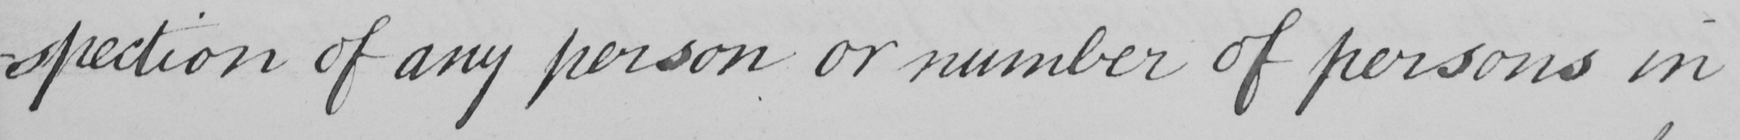What text is written in this handwritten line? -spection of any person or number of persons in 